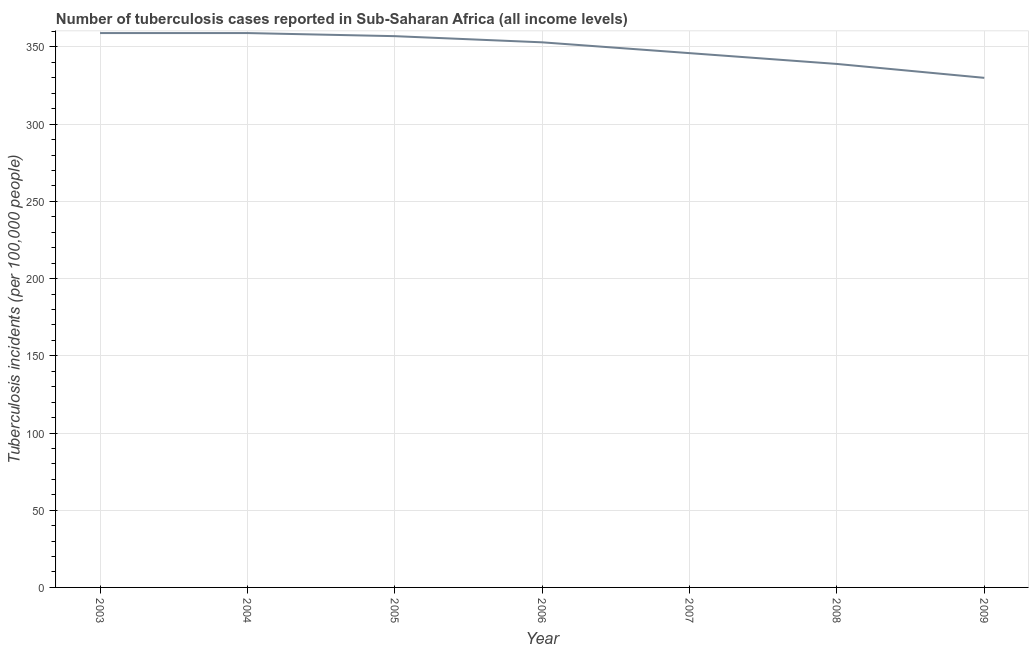What is the number of tuberculosis incidents in 2004?
Your answer should be compact. 359. Across all years, what is the maximum number of tuberculosis incidents?
Ensure brevity in your answer.  359. Across all years, what is the minimum number of tuberculosis incidents?
Provide a succinct answer. 330. In which year was the number of tuberculosis incidents maximum?
Offer a very short reply. 2003. What is the sum of the number of tuberculosis incidents?
Ensure brevity in your answer.  2443. What is the difference between the number of tuberculosis incidents in 2003 and 2007?
Offer a terse response. 13. What is the average number of tuberculosis incidents per year?
Offer a very short reply. 349. What is the median number of tuberculosis incidents?
Your answer should be compact. 353. Do a majority of the years between 2006 and 2005 (inclusive) have number of tuberculosis incidents greater than 140 ?
Make the answer very short. No. What is the ratio of the number of tuberculosis incidents in 2005 to that in 2006?
Offer a terse response. 1.01. Is the number of tuberculosis incidents in 2004 less than that in 2005?
Keep it short and to the point. No. What is the difference between the highest and the second highest number of tuberculosis incidents?
Keep it short and to the point. 0. What is the difference between the highest and the lowest number of tuberculosis incidents?
Keep it short and to the point. 29. Does the number of tuberculosis incidents monotonically increase over the years?
Offer a very short reply. No. How many lines are there?
Your answer should be compact. 1. How many years are there in the graph?
Provide a short and direct response. 7. What is the difference between two consecutive major ticks on the Y-axis?
Offer a very short reply. 50. What is the title of the graph?
Your response must be concise. Number of tuberculosis cases reported in Sub-Saharan Africa (all income levels). What is the label or title of the X-axis?
Give a very brief answer. Year. What is the label or title of the Y-axis?
Provide a short and direct response. Tuberculosis incidents (per 100,0 people). What is the Tuberculosis incidents (per 100,000 people) of 2003?
Offer a terse response. 359. What is the Tuberculosis incidents (per 100,000 people) in 2004?
Keep it short and to the point. 359. What is the Tuberculosis incidents (per 100,000 people) in 2005?
Offer a terse response. 357. What is the Tuberculosis incidents (per 100,000 people) of 2006?
Provide a succinct answer. 353. What is the Tuberculosis incidents (per 100,000 people) of 2007?
Ensure brevity in your answer.  346. What is the Tuberculosis incidents (per 100,000 people) of 2008?
Provide a short and direct response. 339. What is the Tuberculosis incidents (per 100,000 people) of 2009?
Provide a succinct answer. 330. What is the difference between the Tuberculosis incidents (per 100,000 people) in 2003 and 2005?
Give a very brief answer. 2. What is the difference between the Tuberculosis incidents (per 100,000 people) in 2003 and 2007?
Provide a short and direct response. 13. What is the difference between the Tuberculosis incidents (per 100,000 people) in 2004 and 2007?
Keep it short and to the point. 13. What is the difference between the Tuberculosis incidents (per 100,000 people) in 2004 and 2009?
Your answer should be compact. 29. What is the difference between the Tuberculosis incidents (per 100,000 people) in 2005 and 2006?
Give a very brief answer. 4. What is the difference between the Tuberculosis incidents (per 100,000 people) in 2005 and 2008?
Offer a very short reply. 18. What is the difference between the Tuberculosis incidents (per 100,000 people) in 2005 and 2009?
Make the answer very short. 27. What is the difference between the Tuberculosis incidents (per 100,000 people) in 2006 and 2007?
Provide a succinct answer. 7. What is the difference between the Tuberculosis incidents (per 100,000 people) in 2006 and 2008?
Provide a succinct answer. 14. What is the ratio of the Tuberculosis incidents (per 100,000 people) in 2003 to that in 2004?
Provide a succinct answer. 1. What is the ratio of the Tuberculosis incidents (per 100,000 people) in 2003 to that in 2007?
Your answer should be very brief. 1.04. What is the ratio of the Tuberculosis incidents (per 100,000 people) in 2003 to that in 2008?
Ensure brevity in your answer.  1.06. What is the ratio of the Tuberculosis incidents (per 100,000 people) in 2003 to that in 2009?
Your response must be concise. 1.09. What is the ratio of the Tuberculosis incidents (per 100,000 people) in 2004 to that in 2007?
Your answer should be very brief. 1.04. What is the ratio of the Tuberculosis incidents (per 100,000 people) in 2004 to that in 2008?
Offer a terse response. 1.06. What is the ratio of the Tuberculosis incidents (per 100,000 people) in 2004 to that in 2009?
Ensure brevity in your answer.  1.09. What is the ratio of the Tuberculosis incidents (per 100,000 people) in 2005 to that in 2007?
Provide a short and direct response. 1.03. What is the ratio of the Tuberculosis incidents (per 100,000 people) in 2005 to that in 2008?
Your answer should be compact. 1.05. What is the ratio of the Tuberculosis incidents (per 100,000 people) in 2005 to that in 2009?
Make the answer very short. 1.08. What is the ratio of the Tuberculosis incidents (per 100,000 people) in 2006 to that in 2008?
Your answer should be compact. 1.04. What is the ratio of the Tuberculosis incidents (per 100,000 people) in 2006 to that in 2009?
Keep it short and to the point. 1.07. What is the ratio of the Tuberculosis incidents (per 100,000 people) in 2007 to that in 2008?
Provide a succinct answer. 1.02. What is the ratio of the Tuberculosis incidents (per 100,000 people) in 2007 to that in 2009?
Keep it short and to the point. 1.05. What is the ratio of the Tuberculosis incidents (per 100,000 people) in 2008 to that in 2009?
Offer a very short reply. 1.03. 